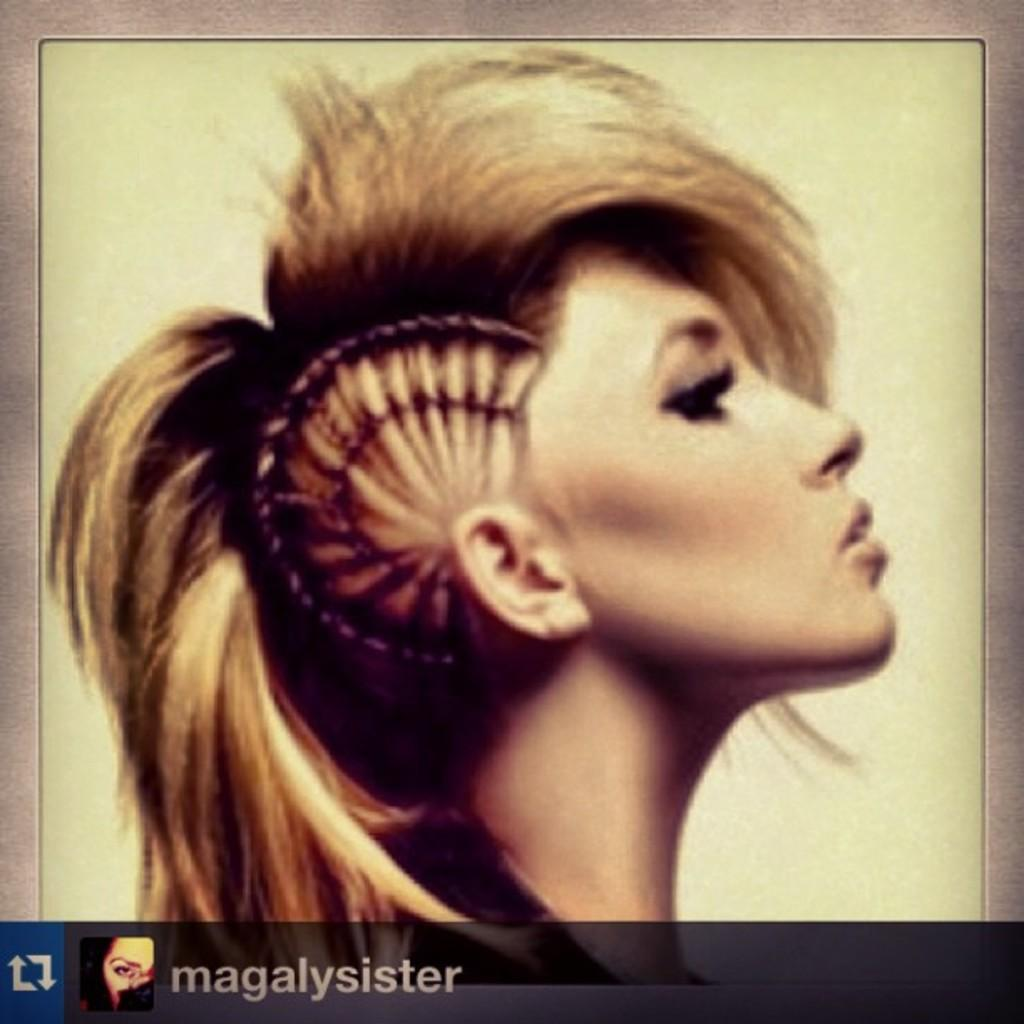Who or what is the main subject in the image? There is a person in the image. What color is the background of the image? The background of the image is white. Is there any text present in the image? Yes, there is text at the bottom of the image. How many feet can be seen in the image? There is no foot visible in the image; it only shows a person. Is there a bat flying in the image? There is no bat present in the image. 